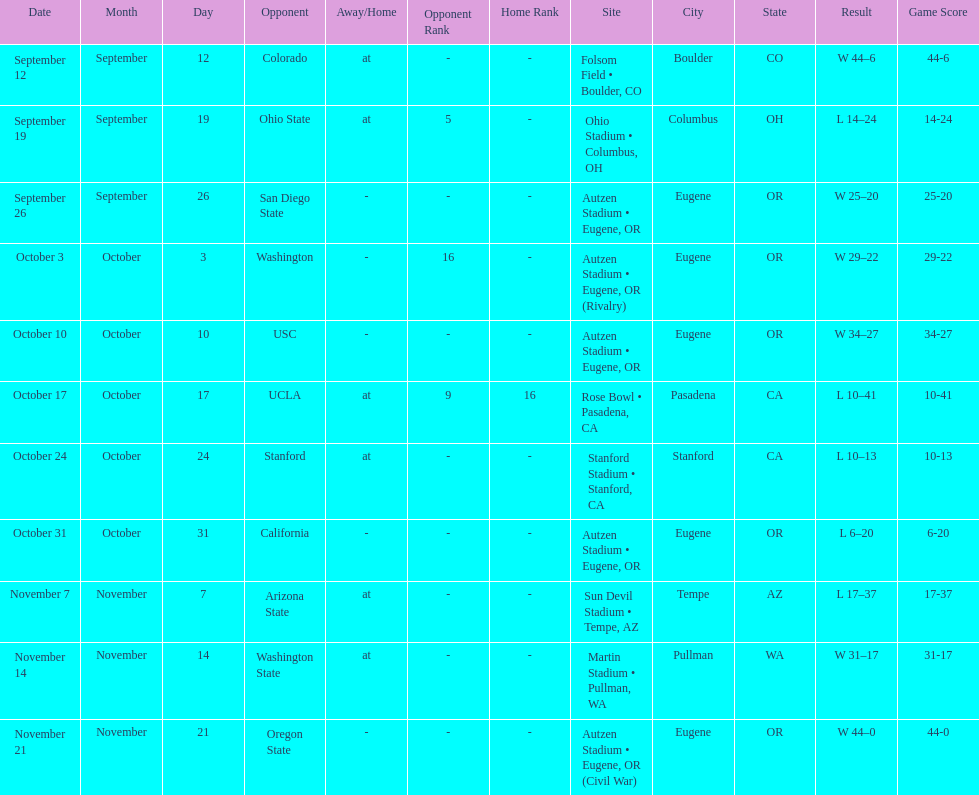Between september 26 and october 24, how many games were played in eugene, or? 3. 